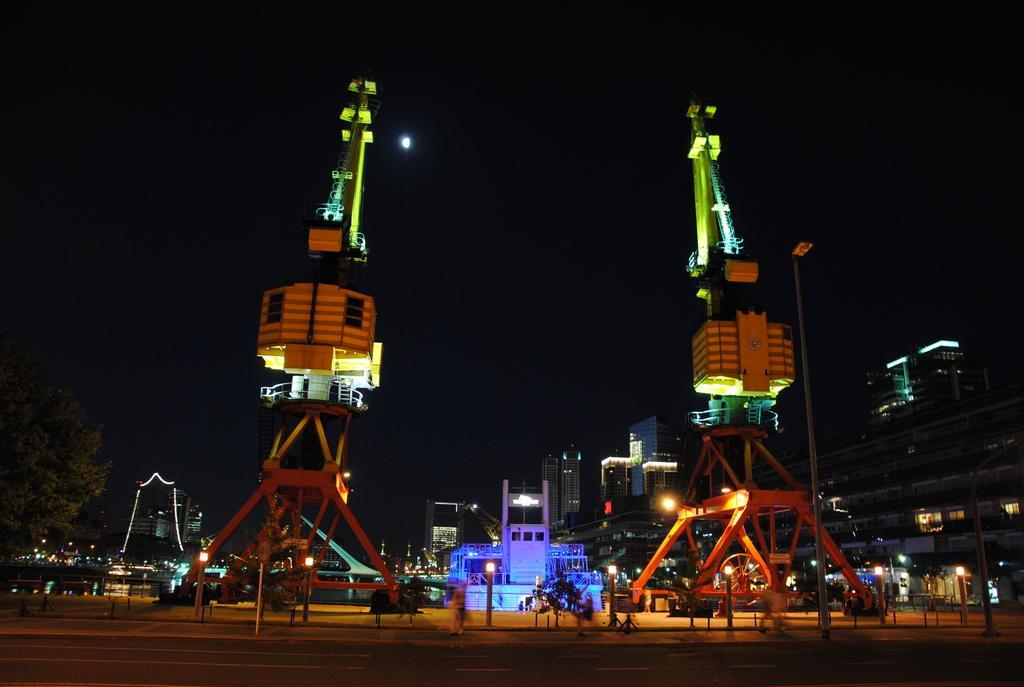How would you summarize this image in a sentence or two? In the image there are two constructions on either sides with lights over it, this is clicked at night side, in the back there are buildings all over the image and above its sky. 